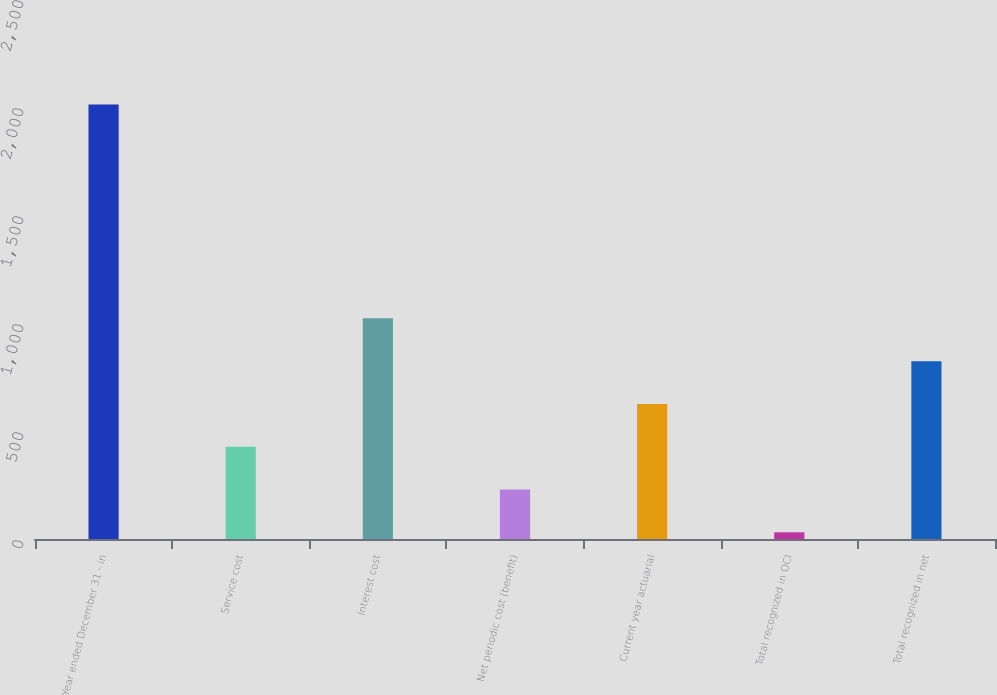Convert chart to OTSL. <chart><loc_0><loc_0><loc_500><loc_500><bar_chart><fcel>Year ended December 31 - in<fcel>Service cost<fcel>Interest cost<fcel>Net periodic cost (benefit)<fcel>Current year actuarial<fcel>Total recognized in OCI<fcel>Total recognized in net<nl><fcel>2012<fcel>427.2<fcel>1021.5<fcel>229.1<fcel>625.3<fcel>31<fcel>823.4<nl></chart> 